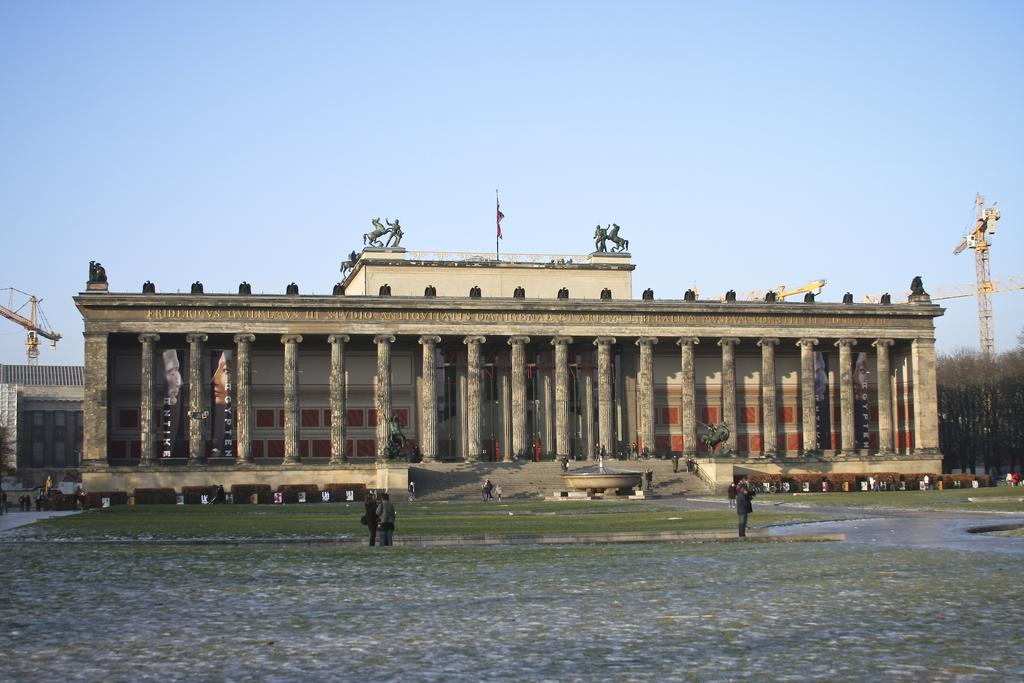What are the people in the image doing? The people in the image are standing on the road. What can be seen in the background of the image? There is a building and two construction cranes visible in the background. What type of thumb can be seen in the image? There is no thumb visible in the image. What agreement was reached by the people in the image? There is no indication of any agreement or discussion among the people in the image. 